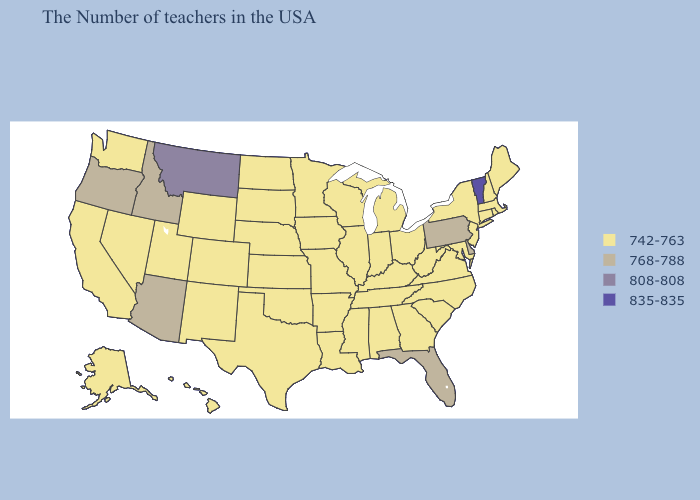Name the states that have a value in the range 768-788?
Answer briefly. Delaware, Pennsylvania, Florida, Arizona, Idaho, Oregon. Does New Jersey have the highest value in the Northeast?
Quick response, please. No. What is the value of Alabama?
Keep it brief. 742-763. What is the value of Alaska?
Write a very short answer. 742-763. Among the states that border Pennsylvania , does Maryland have the highest value?
Answer briefly. No. Name the states that have a value in the range 808-808?
Be succinct. Montana. What is the lowest value in states that border Michigan?
Be succinct. 742-763. What is the value of Idaho?
Quick response, please. 768-788. Which states have the lowest value in the West?
Answer briefly. Wyoming, Colorado, New Mexico, Utah, Nevada, California, Washington, Alaska, Hawaii. Does the first symbol in the legend represent the smallest category?
Concise answer only. Yes. What is the value of California?
Quick response, please. 742-763. Does Pennsylvania have the highest value in the Northeast?
Give a very brief answer. No. What is the value of Kentucky?
Write a very short answer. 742-763. 